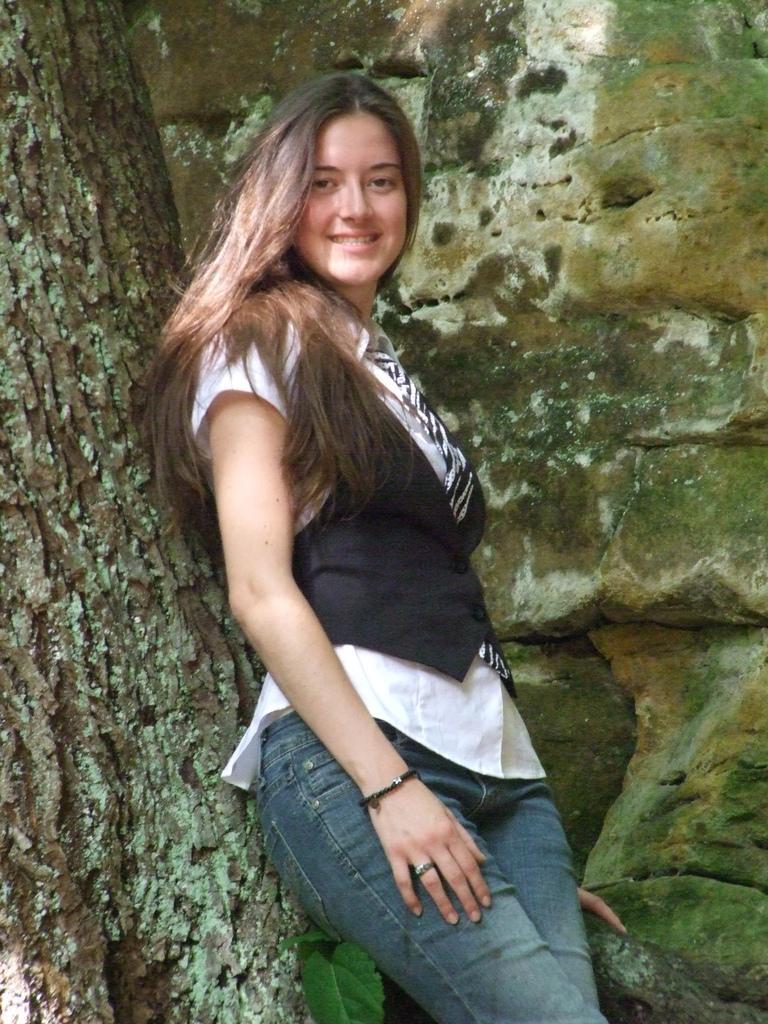How would you summarize this image in a sentence or two? In this image we can see a girl stand and a smile on her face, beside the girl there is a tree, behind the girl there is a wall with rocks. 